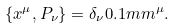<formula> <loc_0><loc_0><loc_500><loc_500>\{ x ^ { \mu } , P _ { \nu } \} = \delta _ { \nu } 0 . 1 m m ^ { \mu } .</formula> 